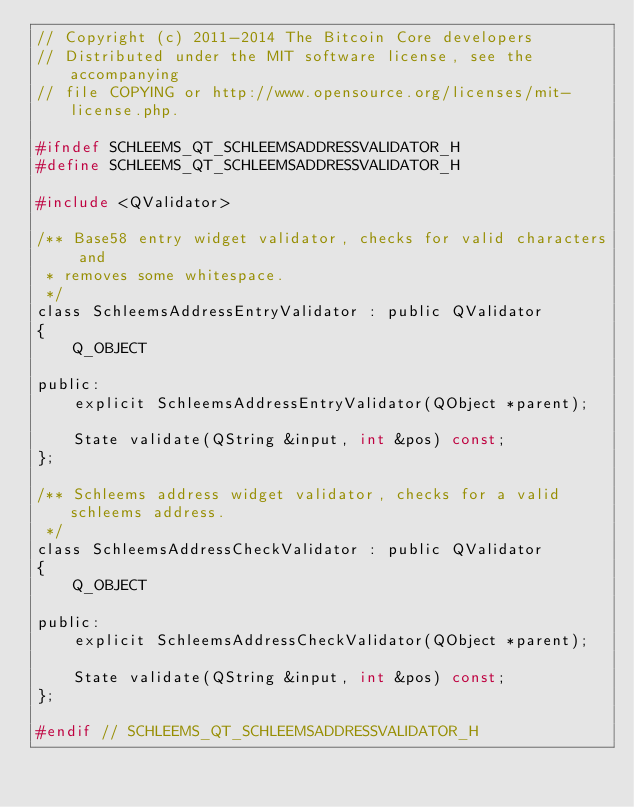Convert code to text. <code><loc_0><loc_0><loc_500><loc_500><_C_>// Copyright (c) 2011-2014 The Bitcoin Core developers
// Distributed under the MIT software license, see the accompanying
// file COPYING or http://www.opensource.org/licenses/mit-license.php.

#ifndef SCHLEEMS_QT_SCHLEEMSADDRESSVALIDATOR_H
#define SCHLEEMS_QT_SCHLEEMSADDRESSVALIDATOR_H

#include <QValidator>

/** Base58 entry widget validator, checks for valid characters and
 * removes some whitespace.
 */
class SchleemsAddressEntryValidator : public QValidator
{
    Q_OBJECT

public:
    explicit SchleemsAddressEntryValidator(QObject *parent);

    State validate(QString &input, int &pos) const;
};

/** Schleems address widget validator, checks for a valid schleems address.
 */
class SchleemsAddressCheckValidator : public QValidator
{
    Q_OBJECT

public:
    explicit SchleemsAddressCheckValidator(QObject *parent);

    State validate(QString &input, int &pos) const;
};

#endif // SCHLEEMS_QT_SCHLEEMSADDRESSVALIDATOR_H
</code> 